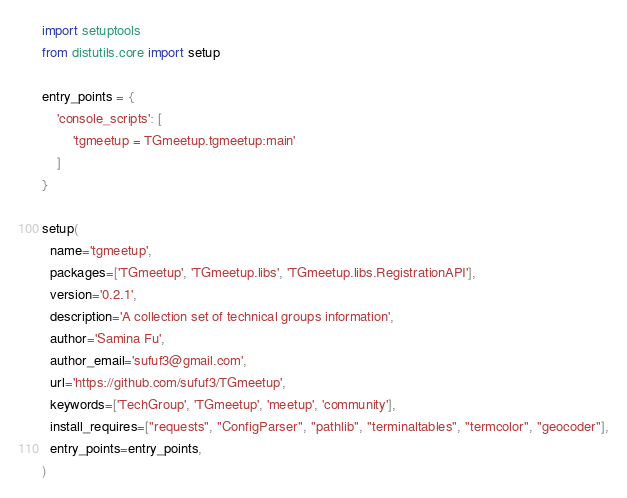Convert code to text. <code><loc_0><loc_0><loc_500><loc_500><_Python_>import setuptools
from distutils.core import setup

entry_points = {
    'console_scripts': [
        'tgmeetup = TGmeetup.tgmeetup:main'
    ]
}

setup(
  name='tgmeetup',
  packages=['TGmeetup', 'TGmeetup.libs', 'TGmeetup.libs.RegistrationAPI'],
  version='0.2.1',
  description='A collection set of technical groups information',
  author='Samina Fu',
  author_email='sufuf3@gmail.com',
  url='https://github.com/sufuf3/TGmeetup',
  keywords=['TechGroup', 'TGmeetup', 'meetup', 'community'],
  install_requires=["requests", "ConfigParser", "pathlib", "terminaltables", "termcolor", "geocoder"],
  entry_points=entry_points,
)
</code> 